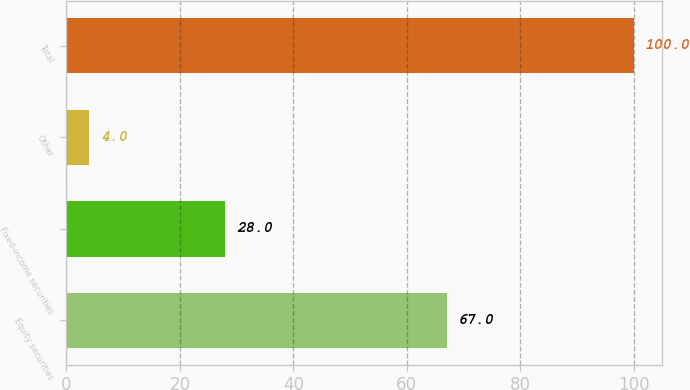Convert chart to OTSL. <chart><loc_0><loc_0><loc_500><loc_500><bar_chart><fcel>Equity securities<fcel>Fixed-income securities<fcel>Other<fcel>Total<nl><fcel>67<fcel>28<fcel>4<fcel>100<nl></chart> 